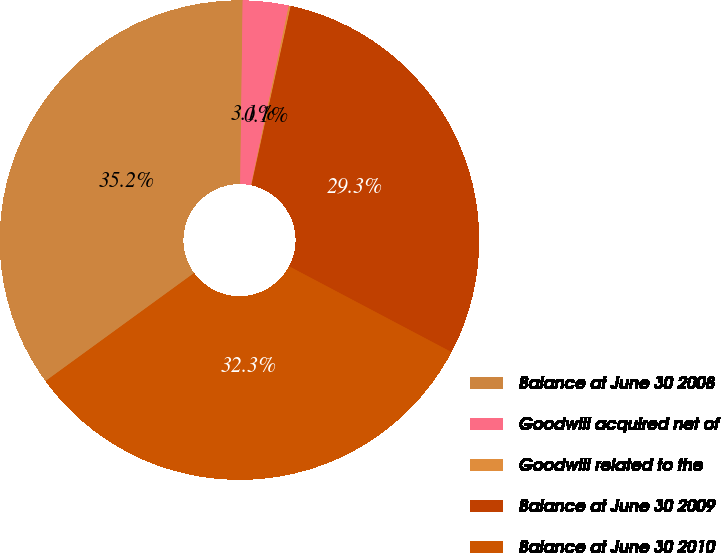<chart> <loc_0><loc_0><loc_500><loc_500><pie_chart><fcel>Balance at June 30 2008<fcel>Goodwill acquired net of<fcel>Goodwill related to the<fcel>Balance at June 30 2009<fcel>Balance at June 30 2010<nl><fcel>35.22%<fcel>3.09%<fcel>0.13%<fcel>29.3%<fcel>32.26%<nl></chart> 